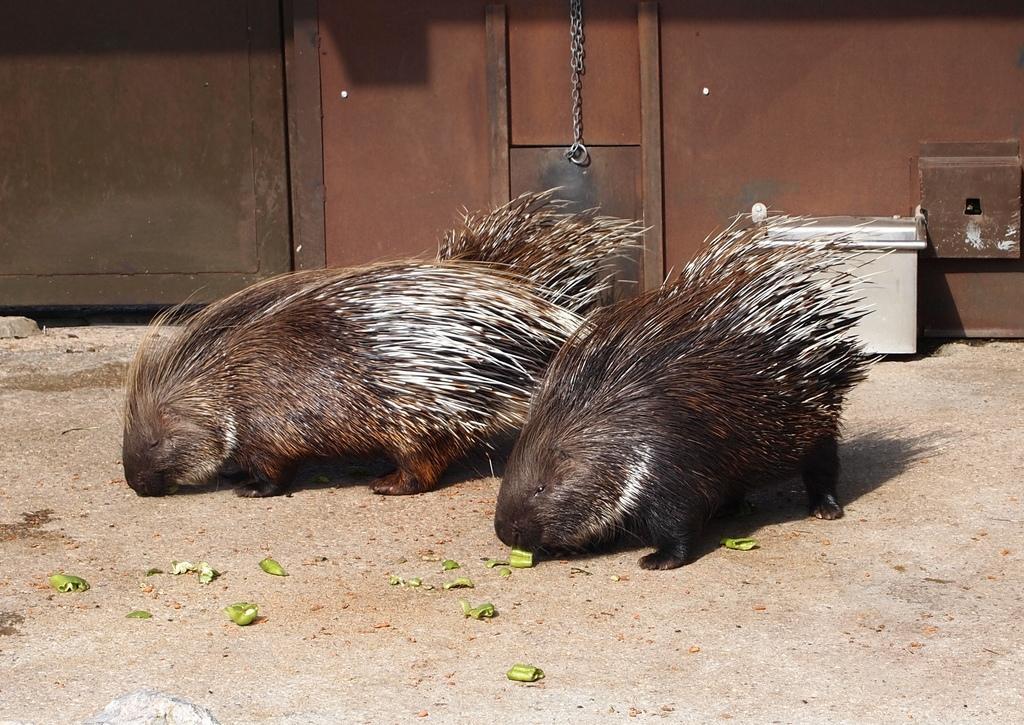Can you describe this image briefly? In this picture I can see couple of porcupines on the ground and I can see couple of metal boxes on the right side and looks like a metal wall in the background. 